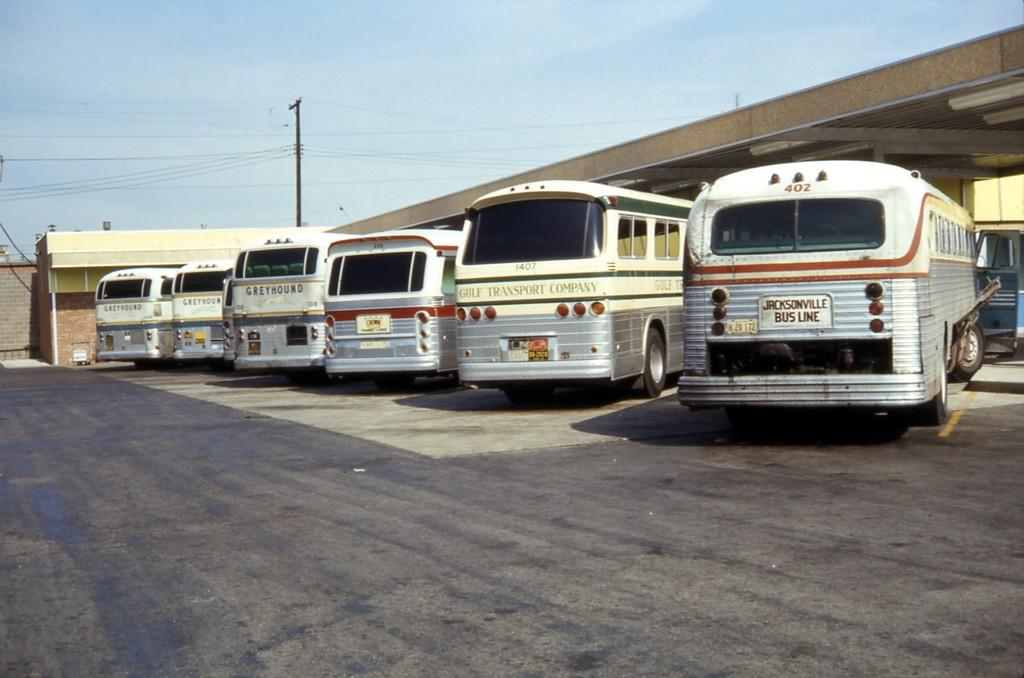What type of vehicles are present in the image? There are buses in the image. Where are the buses located? The buses are parked in a bus station. What colors are the buses? The buses are grey and white in color. What else can be seen in the image besides the buses? There is a pole and wires in the image, and the sky is visible in the background. How much sugar is in the buses in the image? There is no sugar present in the buses or the image; the image features buses parked in a bus station. 